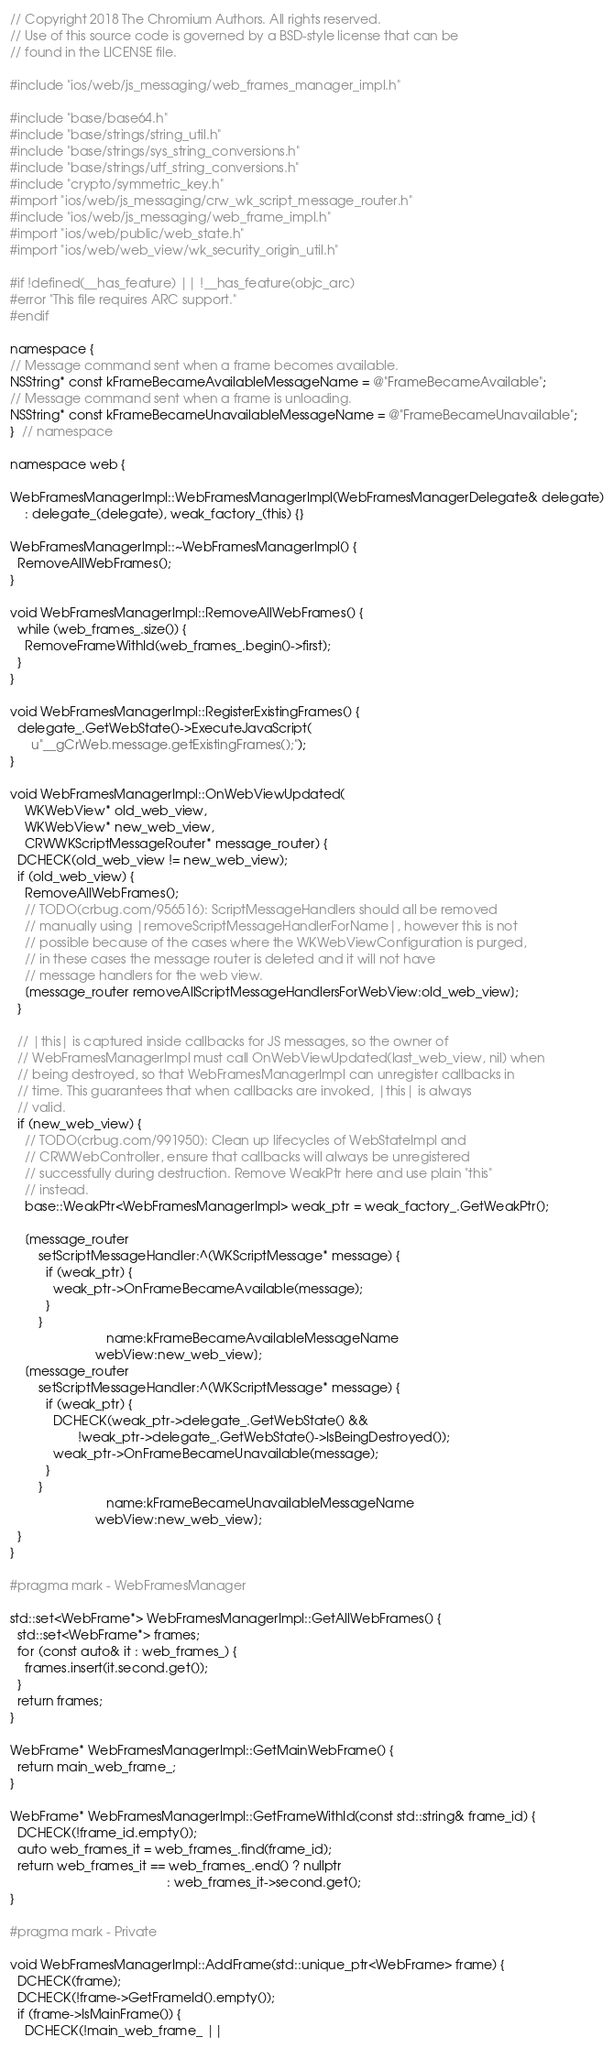<code> <loc_0><loc_0><loc_500><loc_500><_ObjectiveC_>// Copyright 2018 The Chromium Authors. All rights reserved.
// Use of this source code is governed by a BSD-style license that can be
// found in the LICENSE file.

#include "ios/web/js_messaging/web_frames_manager_impl.h"

#include "base/base64.h"
#include "base/strings/string_util.h"
#include "base/strings/sys_string_conversions.h"
#include "base/strings/utf_string_conversions.h"
#include "crypto/symmetric_key.h"
#import "ios/web/js_messaging/crw_wk_script_message_router.h"
#include "ios/web/js_messaging/web_frame_impl.h"
#import "ios/web/public/web_state.h"
#import "ios/web/web_view/wk_security_origin_util.h"

#if !defined(__has_feature) || !__has_feature(objc_arc)
#error "This file requires ARC support."
#endif

namespace {
// Message command sent when a frame becomes available.
NSString* const kFrameBecameAvailableMessageName = @"FrameBecameAvailable";
// Message command sent when a frame is unloading.
NSString* const kFrameBecameUnavailableMessageName = @"FrameBecameUnavailable";
}  // namespace

namespace web {

WebFramesManagerImpl::WebFramesManagerImpl(WebFramesManagerDelegate& delegate)
    : delegate_(delegate), weak_factory_(this) {}

WebFramesManagerImpl::~WebFramesManagerImpl() {
  RemoveAllWebFrames();
}

void WebFramesManagerImpl::RemoveAllWebFrames() {
  while (web_frames_.size()) {
    RemoveFrameWithId(web_frames_.begin()->first);
  }
}

void WebFramesManagerImpl::RegisterExistingFrames() {
  delegate_.GetWebState()->ExecuteJavaScript(
      u"__gCrWeb.message.getExistingFrames();");
}

void WebFramesManagerImpl::OnWebViewUpdated(
    WKWebView* old_web_view,
    WKWebView* new_web_view,
    CRWWKScriptMessageRouter* message_router) {
  DCHECK(old_web_view != new_web_view);
  if (old_web_view) {
    RemoveAllWebFrames();
    // TODO(crbug.com/956516): ScriptMessageHandlers should all be removed
    // manually using |removeScriptMessageHandlerForName|, however this is not
    // possible because of the cases where the WKWebViewConfiguration is purged,
    // in these cases the message router is deleted and it will not have
    // message handlers for the web view.
    [message_router removeAllScriptMessageHandlersForWebView:old_web_view];
  }

  // |this| is captured inside callbacks for JS messages, so the owner of
  // WebFramesManagerImpl must call OnWebViewUpdated(last_web_view, nil) when
  // being destroyed, so that WebFramesManagerImpl can unregister callbacks in
  // time. This guarantees that when callbacks are invoked, |this| is always
  // valid.
  if (new_web_view) {
    // TODO(crbug.com/991950): Clean up lifecycles of WebStateImpl and
    // CRWWebController, ensure that callbacks will always be unregistered
    // successfully during destruction. Remove WeakPtr here and use plain "this"
    // instead.
    base::WeakPtr<WebFramesManagerImpl> weak_ptr = weak_factory_.GetWeakPtr();

    [message_router
        setScriptMessageHandler:^(WKScriptMessage* message) {
          if (weak_ptr) {
            weak_ptr->OnFrameBecameAvailable(message);
          }
        }
                           name:kFrameBecameAvailableMessageName
                        webView:new_web_view];
    [message_router
        setScriptMessageHandler:^(WKScriptMessage* message) {
          if (weak_ptr) {
            DCHECK(weak_ptr->delegate_.GetWebState() &&
                   !weak_ptr->delegate_.GetWebState()->IsBeingDestroyed());
            weak_ptr->OnFrameBecameUnavailable(message);
          }
        }
                           name:kFrameBecameUnavailableMessageName
                        webView:new_web_view];
  }
}

#pragma mark - WebFramesManager

std::set<WebFrame*> WebFramesManagerImpl::GetAllWebFrames() {
  std::set<WebFrame*> frames;
  for (const auto& it : web_frames_) {
    frames.insert(it.second.get());
  }
  return frames;
}

WebFrame* WebFramesManagerImpl::GetMainWebFrame() {
  return main_web_frame_;
}

WebFrame* WebFramesManagerImpl::GetFrameWithId(const std::string& frame_id) {
  DCHECK(!frame_id.empty());
  auto web_frames_it = web_frames_.find(frame_id);
  return web_frames_it == web_frames_.end() ? nullptr
                                            : web_frames_it->second.get();
}

#pragma mark - Private

void WebFramesManagerImpl::AddFrame(std::unique_ptr<WebFrame> frame) {
  DCHECK(frame);
  DCHECK(!frame->GetFrameId().empty());
  if (frame->IsMainFrame()) {
    DCHECK(!main_web_frame_ ||</code> 